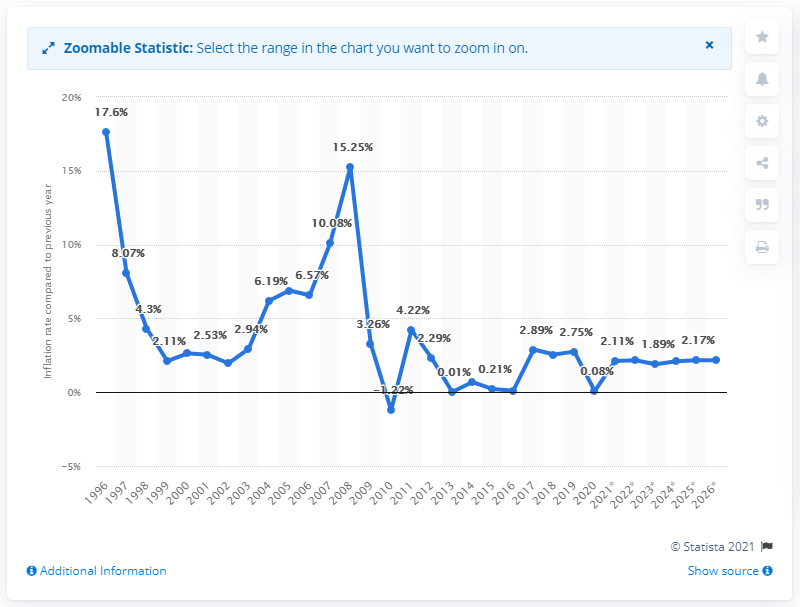Mention a couple of crucial points in this snapshot. According to available data, the inflation rate in Latvia in 2020 was 0.08%. 